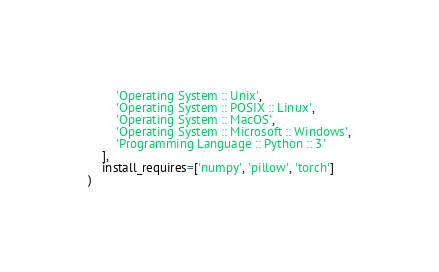<code> <loc_0><loc_0><loc_500><loc_500><_Python_>        'Operating System :: Unix',
        'Operating System :: POSIX :: Linux',
        'Operating System :: MacOS',
        'Operating System :: Microsoft :: Windows',
        'Programming Language :: Python :: 3'
    ],
    install_requires=['numpy', 'pillow', 'torch']
)
</code> 